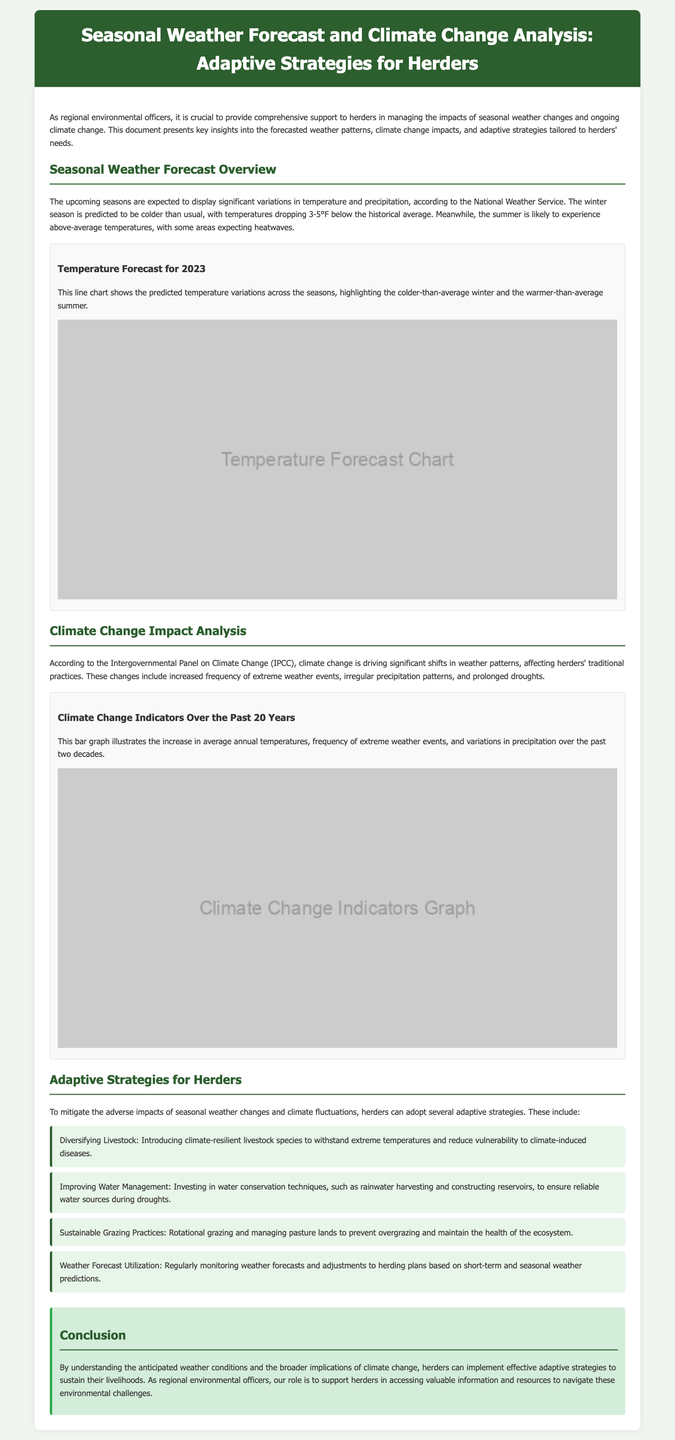What is expected for winter temperatures in 2023? The document states that winter temperatures are predicted to drop 3-5°F below the historical average.
Answer: 3-5°F below What adaptive strategy involves managing pasture lands? The document mentions sustainable grazing practices as an adaptive strategy which includes managing pasture lands.
Answer: Sustainable grazing practices How many years of climate change indicators are illustrated in the graph? The document states that the bar graph illustrates climate change indicators over the past 20 years.
Answer: 20 years What is one benefit of diversifying livestock? The document explains that diversifying livestock introduces climate-resilient species to withstand extreme temperatures.
Answer: Climate-resilient species According to the forecast, what is likely to happen during the summer? The document indicates that summer is likely to experience above-average temperatures.
Answer: Above-average temperatures 